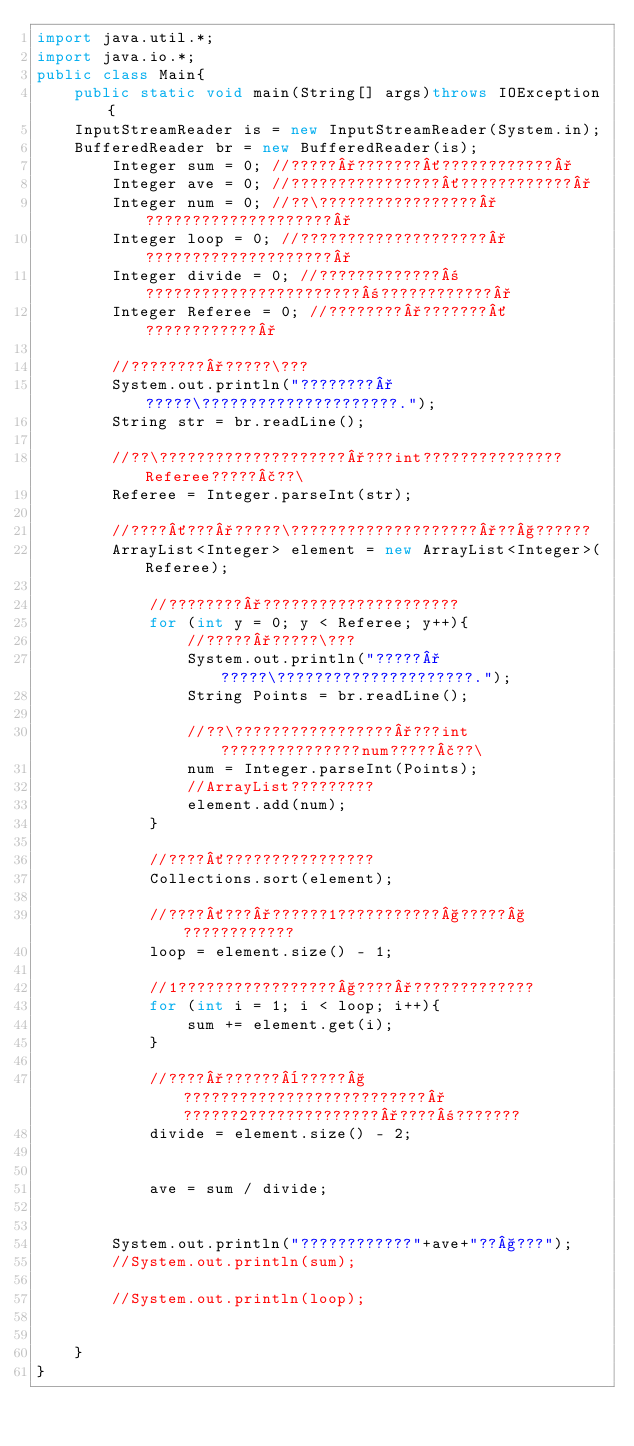Convert code to text. <code><loc_0><loc_0><loc_500><loc_500><_Java_>import java.util.*;
import java.io.*;
public class Main{
    public static void main(String[] args)throws IOException{
    InputStreamReader is = new InputStreamReader(System.in);       
    BufferedReader br = new BufferedReader(is);
        Integer sum = 0; //?????°???????´????????????°
        Integer ave = 0; //????????????????´????????????°
        Integer num = 0; //??\?????????????????°????????????????????°
        Integer loop = 0; //????????????????????°????????????????????°
        Integer divide = 0; //?????????????±???????????????????????±????????????°
        Integer Referee = 0; //????????°???????´????????????°
        
        //????????°?????\???
        System.out.println("????????°?????\?????????????????????.");
        String str = br.readLine();
        
        //??\????????????????????°???int???????????????Referee?????£??\
        Referee = Integer.parseInt(str);
        
        //????´???°?????\????????????????????°??§??????
        ArrayList<Integer> element = new ArrayList<Integer>(Referee);
        
            //????????°?????????????????????
            for (int y = 0; y < Referee; y++){
                //?????°?????\???
                System.out.println("?????°?????\?????????????????????.");
                String Points = br.readLine();
            
                //??\?????????????????°???int???????????????num?????£??\
                num = Integer.parseInt(Points);
                //ArrayList?????????
                element.add(num);
            }
            
            //????´????????????????
            Collections.sort(element);
            
            //????´???°??????1???????????§?????§????????????
            loop = element.size() - 1;
            
            //1?????????????????§????°?????????????
            for (int i = 1; i < loop; i++){
                sum += element.get(i);
            }
            
            //????°??????¨?????§??????????????????????????°??????2??????????????°????±???????
            divide = element.size() - 2;
            
            
            ave = sum / divide;
            
        
        System.out.println("????????????"+ave+"??§???");    
        //System.out.println(sum);   
        
        //System.out.println(loop);
        
        
    }
}</code> 